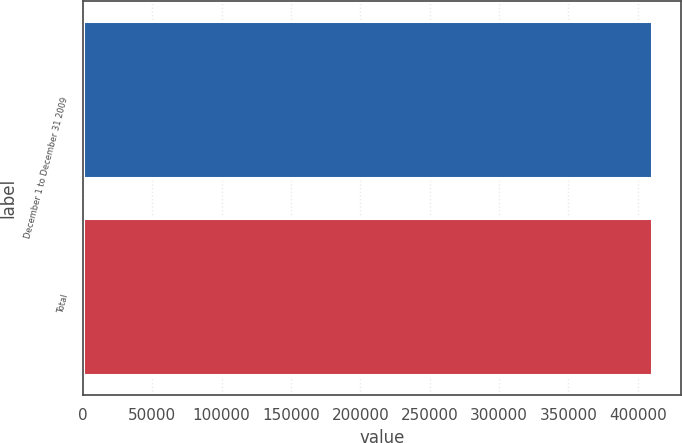Convert chart to OTSL. <chart><loc_0><loc_0><loc_500><loc_500><bar_chart><fcel>December 1 to December 31 2009<fcel>Total<nl><fcel>410603<fcel>410603<nl></chart> 